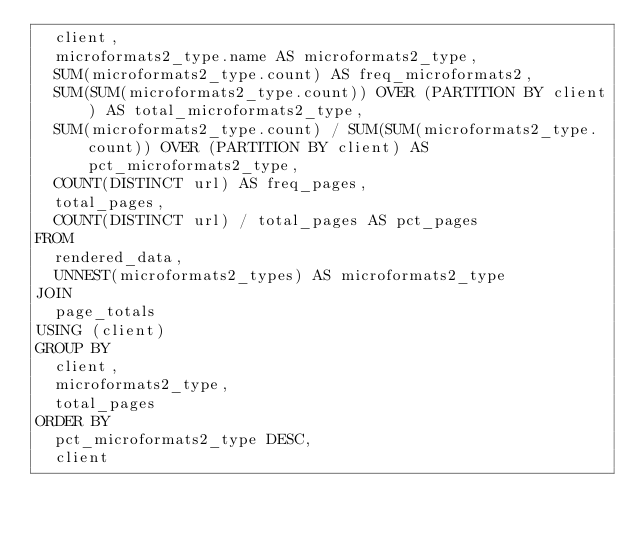Convert code to text. <code><loc_0><loc_0><loc_500><loc_500><_SQL_>  client,
  microformats2_type.name AS microformats2_type,
  SUM(microformats2_type.count) AS freq_microformats2,
  SUM(SUM(microformats2_type.count)) OVER (PARTITION BY client) AS total_microformats2_type,
  SUM(microformats2_type.count) / SUM(SUM(microformats2_type.count)) OVER (PARTITION BY client) AS pct_microformats2_type,
  COUNT(DISTINCT url) AS freq_pages,
  total_pages,
  COUNT(DISTINCT url) / total_pages AS pct_pages
FROM
  rendered_data,
  UNNEST(microformats2_types) AS microformats2_type
JOIN
  page_totals
USING (client)
GROUP BY
  client,
  microformats2_type,
  total_pages
ORDER BY
  pct_microformats2_type DESC,
  client
</code> 